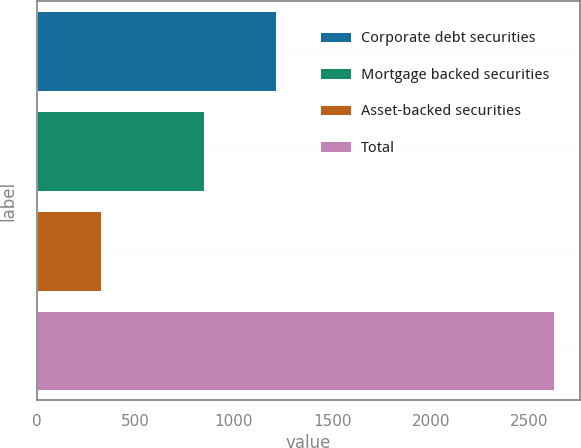Convert chart. <chart><loc_0><loc_0><loc_500><loc_500><bar_chart><fcel>Corporate debt securities<fcel>Mortgage backed securities<fcel>Asset-backed securities<fcel>Total<nl><fcel>1214<fcel>850<fcel>329<fcel>2628<nl></chart> 